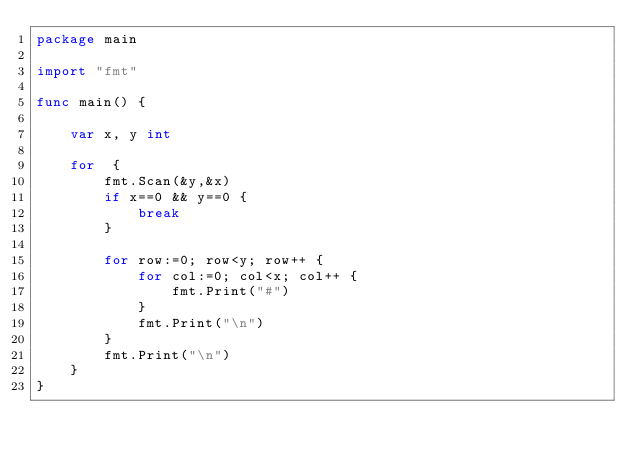<code> <loc_0><loc_0><loc_500><loc_500><_Go_>package main

import "fmt"

func main() {

	var x, y int

	for  {
		fmt.Scan(&y,&x)
		if x==0 && y==0 {
			break
		}

		for row:=0; row<y; row++ {
			for col:=0; col<x; col++ {
				fmt.Print("#")
			}
			fmt.Print("\n")
		}
		fmt.Print("\n")
	}
}
</code> 